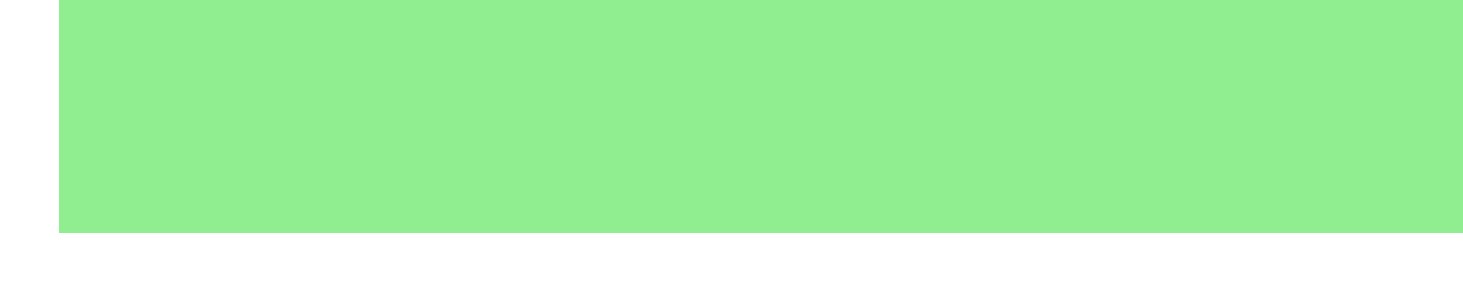What is the pH level of the Vegetable Patch? The pH level for the Vegetable Patch is specified in the document as 6.5.
Answer: 6.5 What recommendation is given for the Rose Garden? The recommendation for the Rose Garden is to add a light layer of lime in spring to prevent further acidification.
Answer: Add a light layer of lime in spring What is the pH level of the Blueberry Patch? The document states that the pH level of the Blueberry Patch is 4.8, which is necessary for blueberry growth.
Answer: 4.8 How often should professional soil tests be conducted? The document indicates that professional soil tests should be conducted once a year for accurate results.
Answer: Once a year Which soil testing method is used for regular monitoring between lab tests? The document refers to using the Home Soil pH Test Kit as the method for regular monitoring.
Answer: Home Soil pH Test Kit What pH adjustment technique is recommended to lower pH in alkaline soils? The document describes the technique of incorporating sulfur to lower pH in alkaline soils.
Answer: Incorporating Sulfur What pH level is considered ideal for most vegetables? The ideal pH level for most vegetables, according to the document, is stated as 6.5.
Answer: 6.5 Which herb showed signs of nutrient deficiency in the Herb Garden? The document notes that basil shows signs of nutrient deficiency in the Herb Garden.
Answer: Basil What is one action item listed in the conclusion? The conclusion lists scheduling a professional soil test for next spring as one action item.
Answer: Schedule professional soil test for next spring 